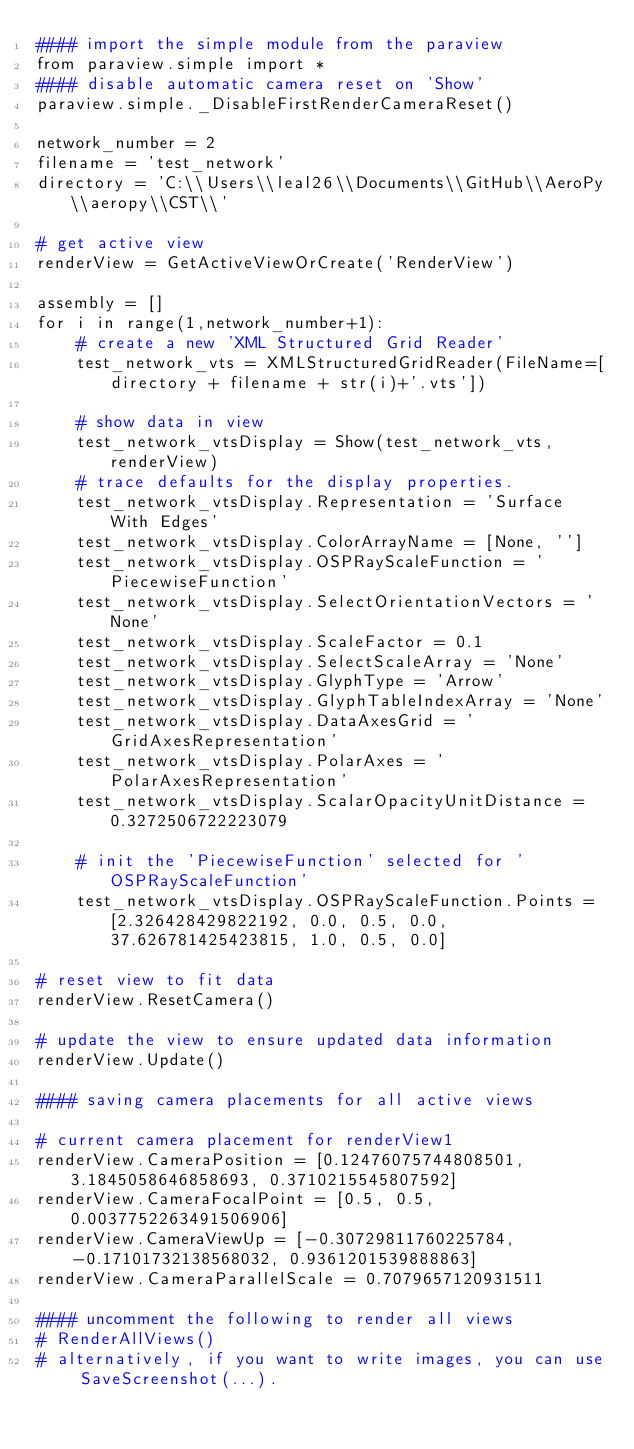<code> <loc_0><loc_0><loc_500><loc_500><_Python_>#### import the simple module from the paraview
from paraview.simple import *
#### disable automatic camera reset on 'Show'
paraview.simple._DisableFirstRenderCameraReset()

network_number = 2
filename = 'test_network'
directory = 'C:\\Users\\leal26\\Documents\\GitHub\\AeroPy\\aeropy\\CST\\'

# get active view
renderView = GetActiveViewOrCreate('RenderView')

assembly = []
for i in range(1,network_number+1):
    # create a new 'XML Structured Grid Reader'
    test_network_vts = XMLStructuredGridReader(FileName=[directory + filename + str(i)+'.vts'])

    # show data in view
    test_network_vtsDisplay = Show(test_network_vts, renderView)
    # trace defaults for the display properties.
    test_network_vtsDisplay.Representation = 'Surface With Edges'
    test_network_vtsDisplay.ColorArrayName = [None, '']
    test_network_vtsDisplay.OSPRayScaleFunction = 'PiecewiseFunction'
    test_network_vtsDisplay.SelectOrientationVectors = 'None'
    test_network_vtsDisplay.ScaleFactor = 0.1
    test_network_vtsDisplay.SelectScaleArray = 'None'
    test_network_vtsDisplay.GlyphType = 'Arrow'
    test_network_vtsDisplay.GlyphTableIndexArray = 'None'
    test_network_vtsDisplay.DataAxesGrid = 'GridAxesRepresentation'
    test_network_vtsDisplay.PolarAxes = 'PolarAxesRepresentation'
    test_network_vtsDisplay.ScalarOpacityUnitDistance = 0.3272506722223079

    # init the 'PiecewiseFunction' selected for 'OSPRayScaleFunction'
    test_network_vtsDisplay.OSPRayScaleFunction.Points = [2.326428429822192, 0.0, 0.5, 0.0, 37.626781425423815, 1.0, 0.5, 0.0]

# reset view to fit data
renderView.ResetCamera()

# update the view to ensure updated data information
renderView.Update()

#### saving camera placements for all active views

# current camera placement for renderView1
renderView.CameraPosition = [0.12476075744808501, 3.1845058646858693, 0.3710215545807592]
renderView.CameraFocalPoint = [0.5, 0.5, 0.0037752263491506906]
renderView.CameraViewUp = [-0.30729811760225784, -0.17101732138568032, 0.9361201539888863]
renderView.CameraParallelScale = 0.7079657120931511

#### uncomment the following to render all views
# RenderAllViews()
# alternatively, if you want to write images, you can use SaveScreenshot(...).</code> 